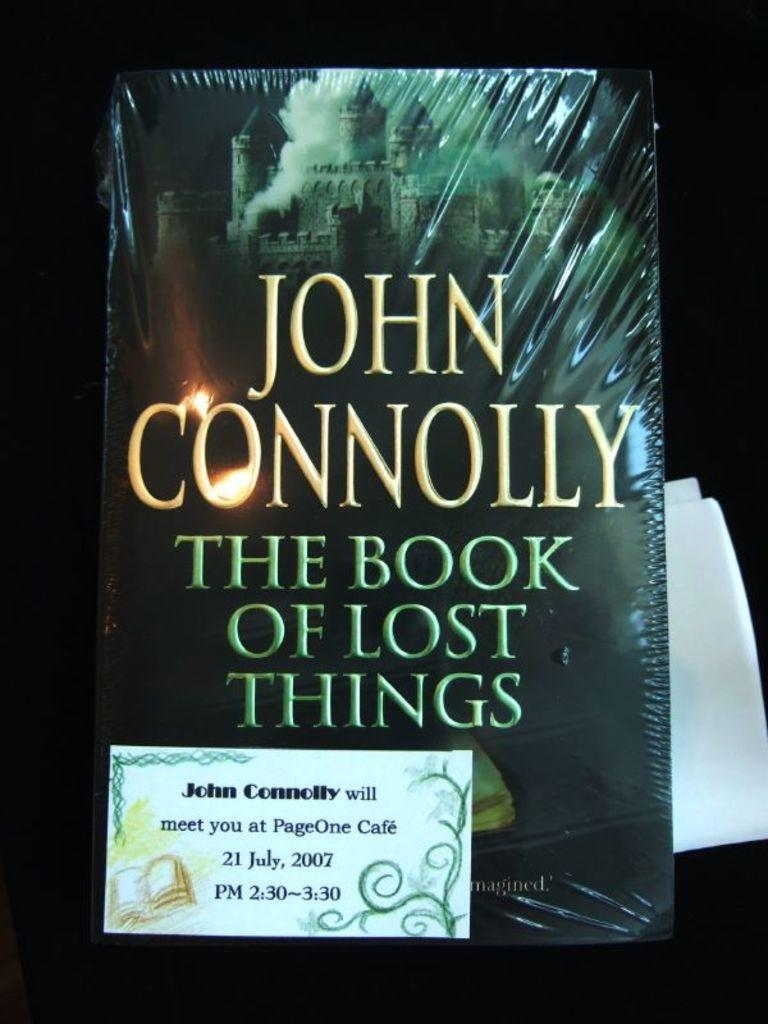<image>
Describe the image concisely. The Book of Lost Things that is written by John Connolly. 